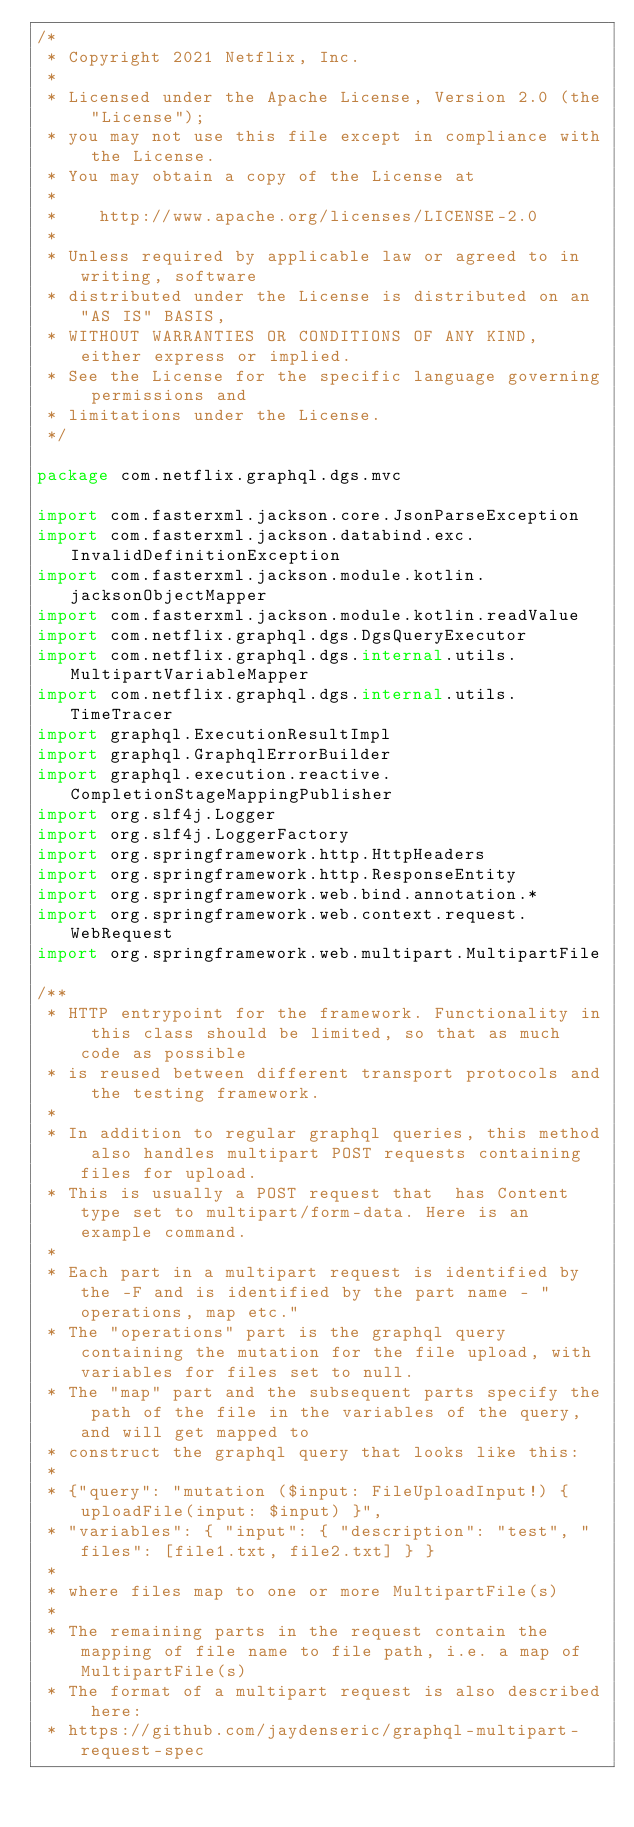Convert code to text. <code><loc_0><loc_0><loc_500><loc_500><_Kotlin_>/*
 * Copyright 2021 Netflix, Inc.
 *
 * Licensed under the Apache License, Version 2.0 (the "License");
 * you may not use this file except in compliance with the License.
 * You may obtain a copy of the License at
 *
 *    http://www.apache.org/licenses/LICENSE-2.0
 *
 * Unless required by applicable law or agreed to in writing, software
 * distributed under the License is distributed on an "AS IS" BASIS,
 * WITHOUT WARRANTIES OR CONDITIONS OF ANY KIND, either express or implied.
 * See the License for the specific language governing permissions and
 * limitations under the License.
 */

package com.netflix.graphql.dgs.mvc

import com.fasterxml.jackson.core.JsonParseException
import com.fasterxml.jackson.databind.exc.InvalidDefinitionException
import com.fasterxml.jackson.module.kotlin.jacksonObjectMapper
import com.fasterxml.jackson.module.kotlin.readValue
import com.netflix.graphql.dgs.DgsQueryExecutor
import com.netflix.graphql.dgs.internal.utils.MultipartVariableMapper
import com.netflix.graphql.dgs.internal.utils.TimeTracer
import graphql.ExecutionResultImpl
import graphql.GraphqlErrorBuilder
import graphql.execution.reactive.CompletionStageMappingPublisher
import org.slf4j.Logger
import org.slf4j.LoggerFactory
import org.springframework.http.HttpHeaders
import org.springframework.http.ResponseEntity
import org.springframework.web.bind.annotation.*
import org.springframework.web.context.request.WebRequest
import org.springframework.web.multipart.MultipartFile

/**
 * HTTP entrypoint for the framework. Functionality in this class should be limited, so that as much code as possible
 * is reused between different transport protocols and the testing framework.
 *
 * In addition to regular graphql queries, this method also handles multipart POST requests containing files for upload.
 * This is usually a POST request that  has Content type set to multipart/form-data. Here is an example command.
 *
 * Each part in a multipart request is identified by the -F and is identified by the part name - "operations, map etc."
 * The "operations" part is the graphql query containing the mutation for the file upload, with variables for files set to null.
 * The "map" part and the subsequent parts specify the path of the file in the variables of the query, and will get mapped to
 * construct the graphql query that looks like this:
 *
 * {"query": "mutation ($input: FileUploadInput!) { uploadFile(input: $input) }",
 * "variables": { "input": { "description": "test", "files": [file1.txt, file2.txt] } }
 *
 * where files map to one or more MultipartFile(s)
 *
 * The remaining parts in the request contain the mapping of file name to file path, i.e. a map of MultipartFile(s)
 * The format of a multipart request is also described here:
 * https://github.com/jaydenseric/graphql-multipart-request-spec</code> 